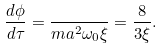<formula> <loc_0><loc_0><loc_500><loc_500>\frac { d \phi } { d \tau } = \frac { } { m a ^ { 2 } \omega _ { 0 } \xi } = \frac { 8 } { 3 \xi } .</formula> 